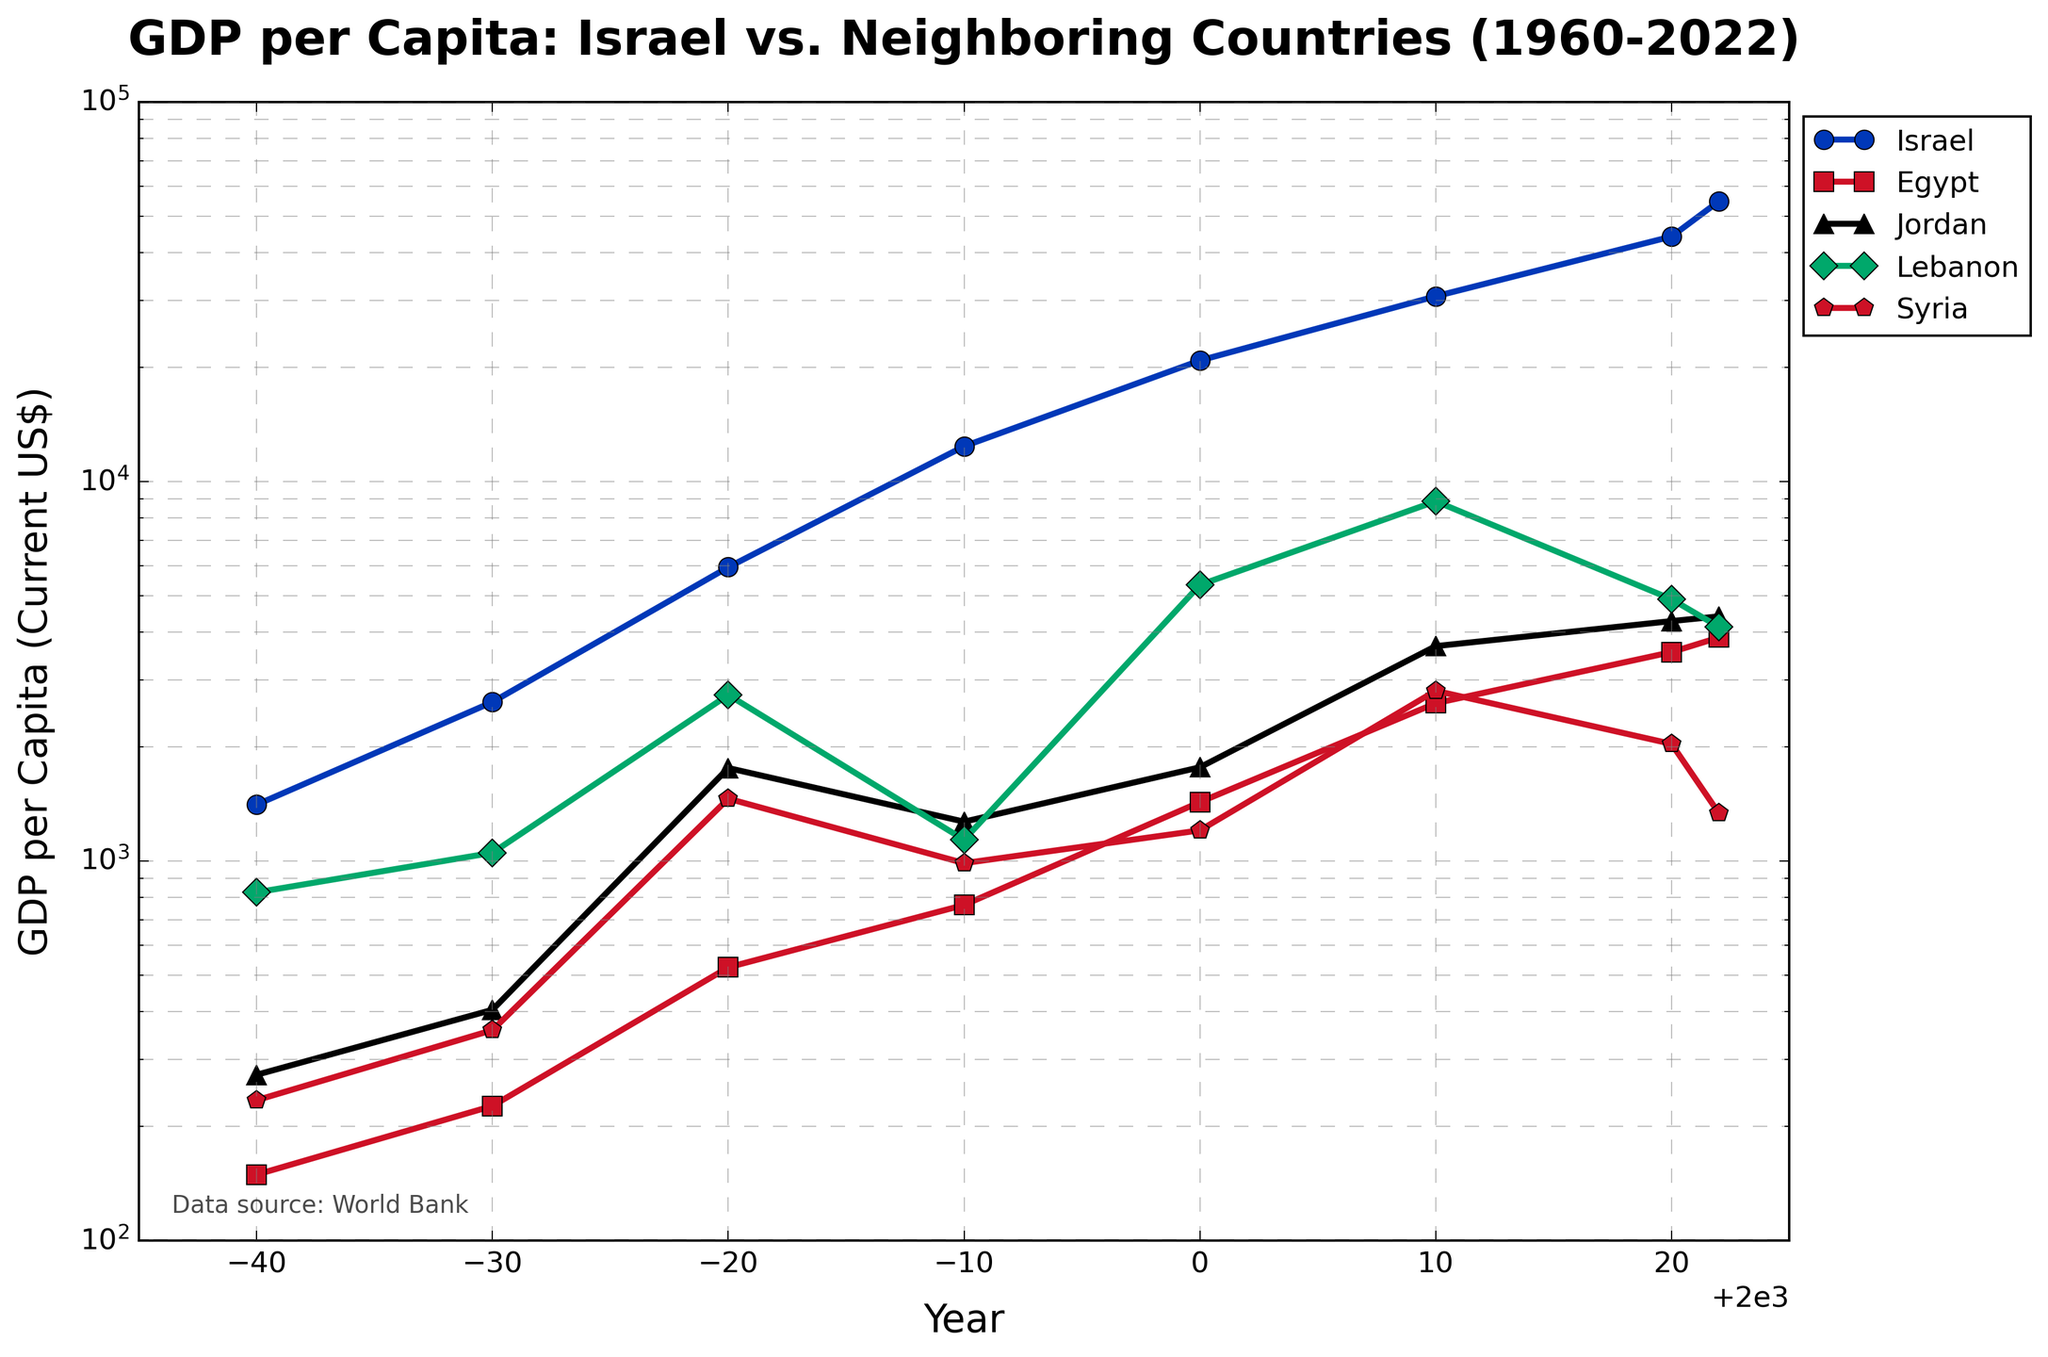Which country had the highest GDP per capita in 2022? To find the country with the highest GDP per capita in 2022, look at the endpoints of the lines for each country in the figure. Israel has the highest endpoint in 2022.
Answer: Israel How did Israel's GDP per capita change between 1960 and 2022? Identify Israel's GDP per capita values in 1960 and 2022 from the plot and subtract the 1960 value from the 2022 value. The values are 1406 in 1960 and 54658 in 2022. The change is 54658 - 1406.
Answer: 53252 Which country showed the least growth in GDP per capita from 1960 to 2022? By comparing the growth of GDP per capita for each country from 1960 to 2022, we observe that Syria's line demonstrates the least change, starting at 234 in 1960 and reaching only 1337 in 2022.
Answer: Syria Did Israel's GDP per capita ever decrease between any two time points? By observing the trajectory of Israel's GDP per capita line, we can see that it consistently rises without any dips between the years indicated.
Answer: No In which decade did Israel exhibit the most significant increase in GDP per capita? By examining the slope of Israel's line for each decade, you can determine that the steepest slope, indicating the greatest increase, occurs between 1990 and 2000.
Answer: 1990-2000 How does Lebanon's GDP per capita in 2000 compare to its GDP per capita in 2022? Lebanon's GDP per capita is observed to be 5335 in 2000 and 4136 in 2022. Comparing these values, we see that it decreased.
Answer: Lebanon's GDP per capita decreased Which country's GDP per capita was most similar to Jordan’s in 2020? By finding Jordan's GDP per capita in 2020 which is 4283, and comparing it to other countries, Lebanon's GDP per capita of 4891 is the closest.
Answer: Lebanon Rank the countries by their GDP per capita in 1970 from highest to lowest. For 1970, find the GDP per capita values for each country: Israel (2621), Lebanon (1050), Syria (358), Jordan (405), and Egypt (226). Rank them accordingly.
Answer: Israel, Lebanon, Jordan, Syria, Egypt What is the approximate ratio between Israel’s GDP per capita and Egypt’s GDP per capita in 2010? Israel's GDP per capita in 2010 is 30736 and Egypt’s is 2602. The ratio is 30736/2602.
Answer: Approximately 11.8 Which country had the highest GDP per capita growth rate between 1980 and 2020? Calculate the growth rates by examining the values at 1980 and 2020. Israel's GDP per capita increased from 5940 to 44168, clearly indicating the highest growth rate among the countries shown.
Answer: Israel 